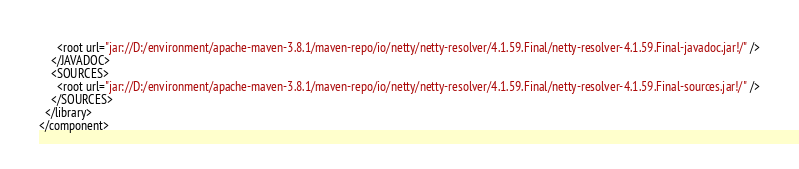<code> <loc_0><loc_0><loc_500><loc_500><_XML_>      <root url="jar://D:/environment/apache-maven-3.8.1/maven-repo/io/netty/netty-resolver/4.1.59.Final/netty-resolver-4.1.59.Final-javadoc.jar!/" />
    </JAVADOC>
    <SOURCES>
      <root url="jar://D:/environment/apache-maven-3.8.1/maven-repo/io/netty/netty-resolver/4.1.59.Final/netty-resolver-4.1.59.Final-sources.jar!/" />
    </SOURCES>
  </library>
</component></code> 